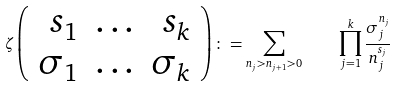<formula> <loc_0><loc_0><loc_500><loc_500>\zeta \left ( \begin{array} { r c r } { { s _ { 1 } } } & { \dots } & { { s _ { k } } } \\ { { \sigma _ { 1 } } } & { \dots } & { { \sigma _ { k } } } \end{array} \right ) \colon = \sum _ { n _ { j } > n _ { j + 1 } > 0 } \quad \prod _ { j = 1 } ^ { k } \frac { \sigma _ { j } ^ { n _ { j } } } { n _ { j } ^ { s _ { j } } }</formula> 